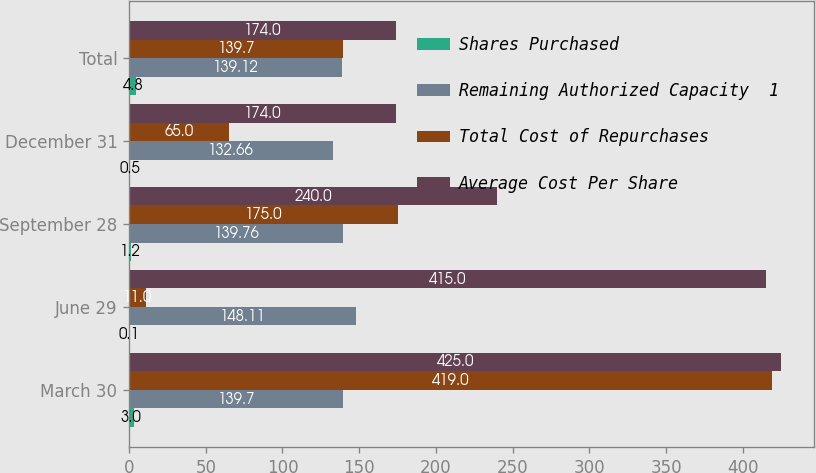Convert chart to OTSL. <chart><loc_0><loc_0><loc_500><loc_500><stacked_bar_chart><ecel><fcel>March 30<fcel>June 29<fcel>September 28<fcel>December 31<fcel>Total<nl><fcel>Shares Purchased<fcel>3<fcel>0.1<fcel>1.2<fcel>0.5<fcel>4.8<nl><fcel>Remaining Authorized Capacity  1<fcel>139.7<fcel>148.11<fcel>139.76<fcel>132.66<fcel>139.12<nl><fcel>Total Cost of Repurchases<fcel>419<fcel>11<fcel>175<fcel>65<fcel>139.7<nl><fcel>Average Cost Per Share<fcel>425<fcel>415<fcel>240<fcel>174<fcel>174<nl></chart> 